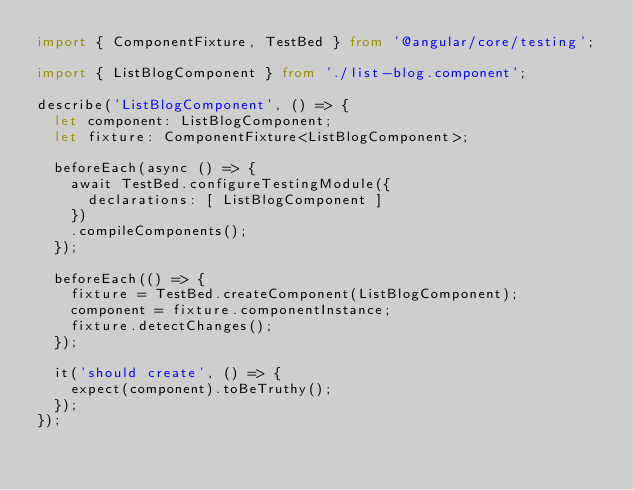Convert code to text. <code><loc_0><loc_0><loc_500><loc_500><_TypeScript_>import { ComponentFixture, TestBed } from '@angular/core/testing';

import { ListBlogComponent } from './list-blog.component';

describe('ListBlogComponent', () => {
  let component: ListBlogComponent;
  let fixture: ComponentFixture<ListBlogComponent>;

  beforeEach(async () => {
    await TestBed.configureTestingModule({
      declarations: [ ListBlogComponent ]
    })
    .compileComponents();
  });

  beforeEach(() => {
    fixture = TestBed.createComponent(ListBlogComponent);
    component = fixture.componentInstance;
    fixture.detectChanges();
  });

  it('should create', () => {
    expect(component).toBeTruthy();
  });
});
</code> 